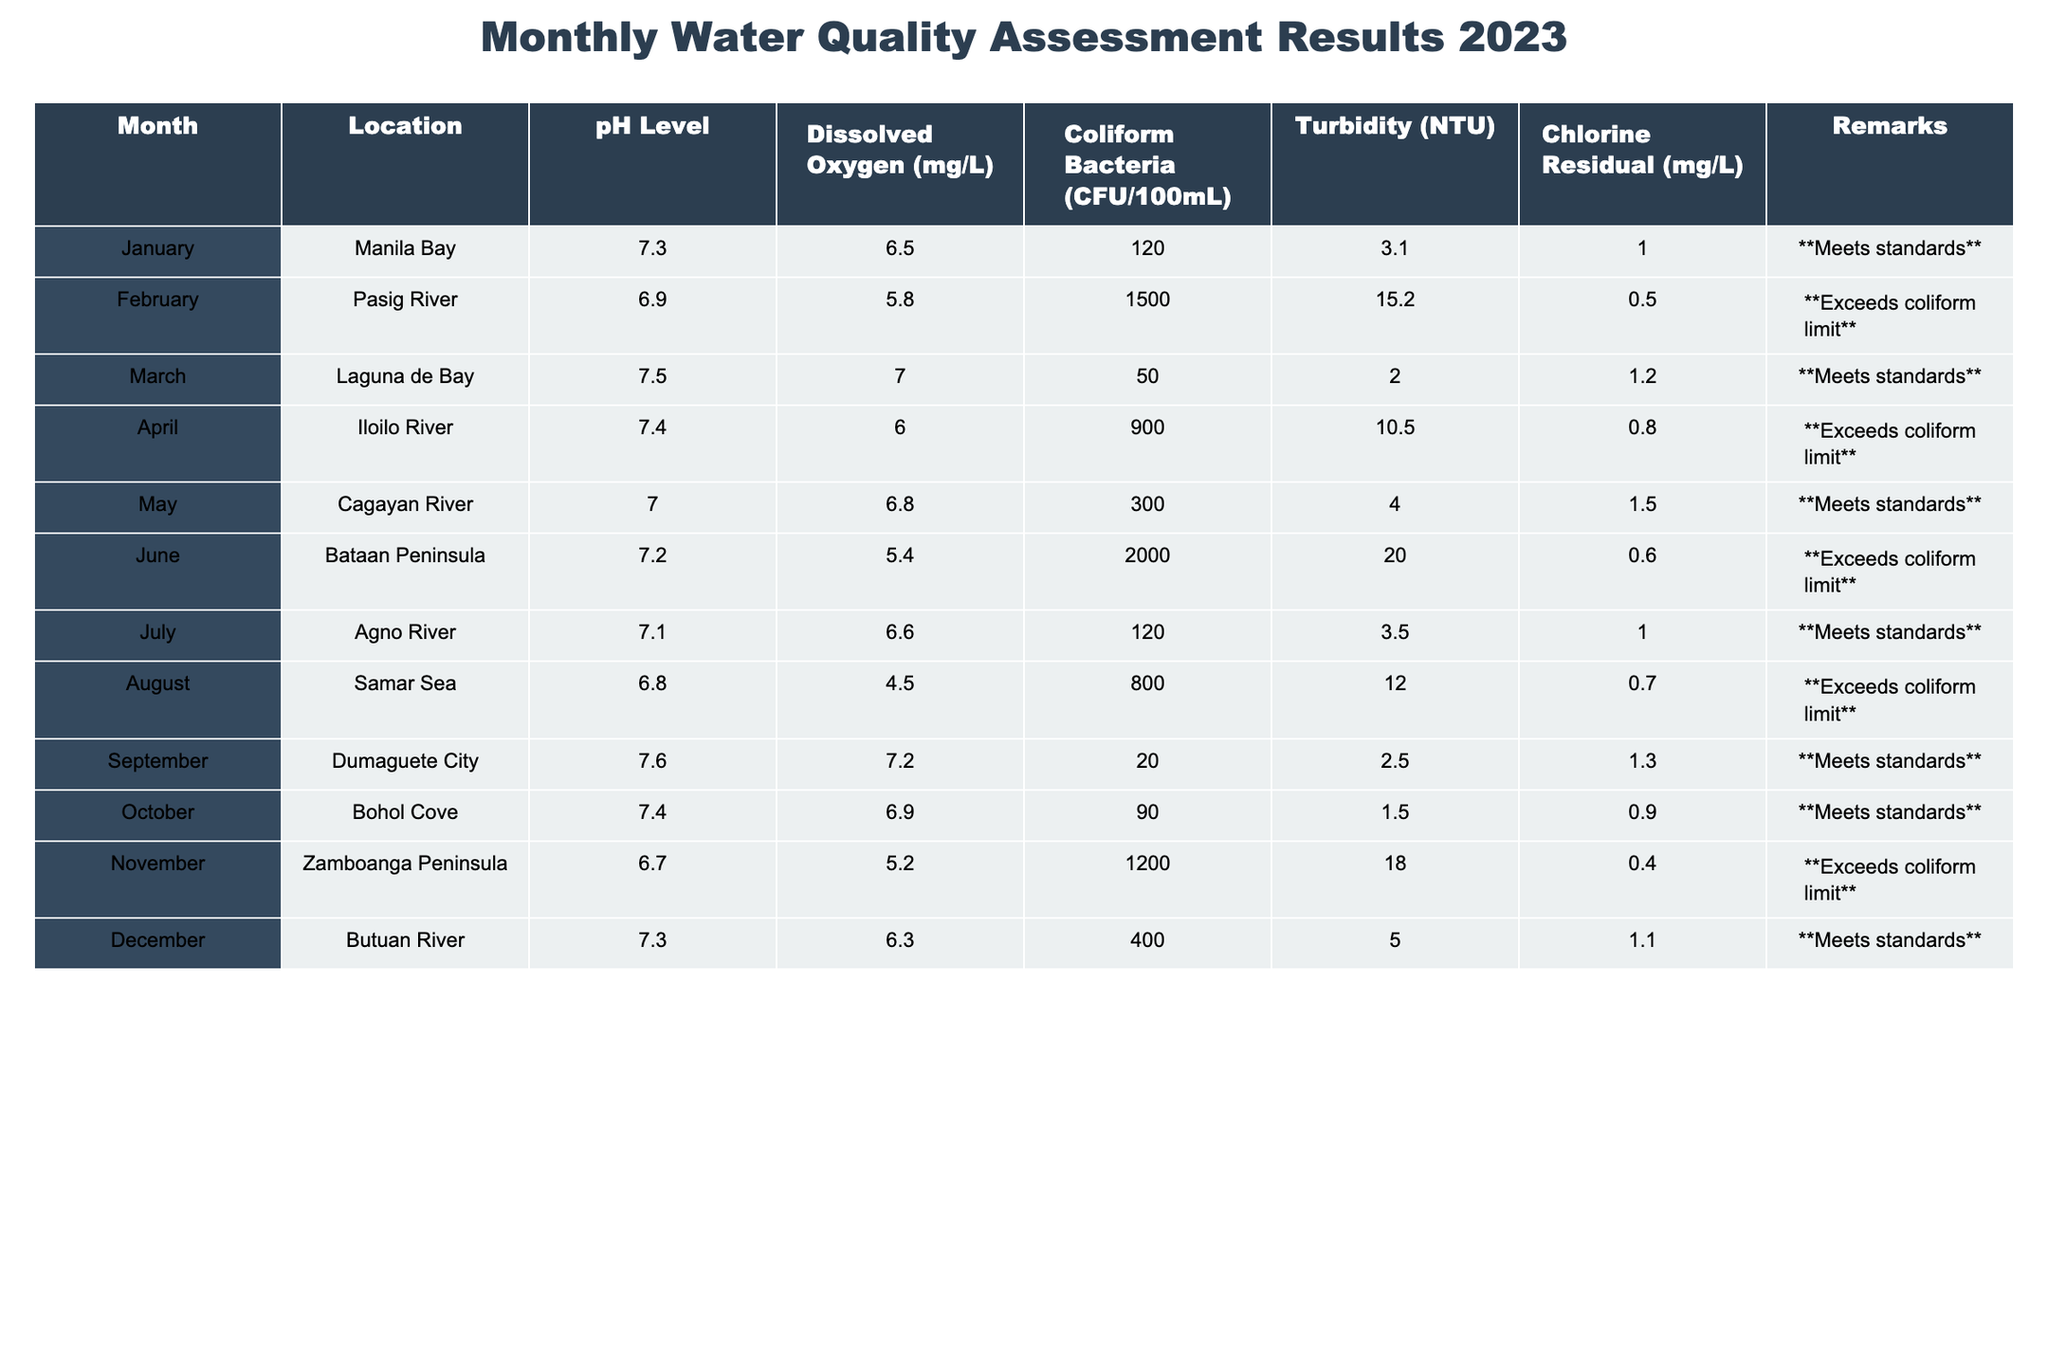What is the pH level of Pasig River in February? The table shows the pH level for Pasig River listed under February as 6.9.
Answer: 6.9 Which month had the highest dissolved oxygen level? By scanning the column for dissolved oxygen levels, March for Laguna de Bay has the highest value at 7.0 mg/L.
Answer: March What are the chlorine residual levels for locations that exceed coliform limits? Checking the records for exceeds coliform limits, they are: February (0.5 mg/L), April (0.8 mg/L), June (0.6 mg/L), August (0.7 mg/L), and November (0.4 mg/L).
Answer: 0.5, 0.8, 0.6, 0.7, 0.4 How many months had water quality that met standards? The months with water quality that met standards are January, March, May, July, September, October, and December. This totals to 7 months.
Answer: 7 What is the average turbidity level for the locations that meet standards? The turbidity levels for the months that meet standards are 3.1, 2.0, 4.0, 3.5, 2.5, 1.5, and 5.0 NTU. Their sum is 21.6, divided by 7 gives an average of 3.09 NTU.
Answer: 3.09 Did any of the months in the table meet the chlorine residual standard? Looking at chlorine residual levels, the values are 1.0, 1.2, 1.5, 1.0, 1.3, 0.9, and 1.1 mg/L for the months that meet standards, which indicates that they all meet the chlorine residual standard.
Answer: Yes Which location had the highest level of coliform bacteria and in which month? The table shows that Bataan Peninsula in June recorded the highest coliform bacteria level at 2000 CFU/100mL.
Answer: Bataan Peninsula, June How does the average pH level of locations exceeding coliform limits compare to those that meet standards? The locations exceeding coliform limits have pH levels of 6.9, 7.4, 6.8, and 6.7, resulting in an average of 6.775. The locations meeting standards have pH levels of 7.3, 7.5, 7.0, 7.4, 7.1, 7.6, 7.4, and 7.3, averaging 7.35. Comparing the two averages: 6.775 is lower than 7.35.
Answer: Exceeding limits have lower average pH What percentage of locations exceeded coliform limits? Counting the months, 5 out of the total 12 months indicated exceeding coliform limits, so the calculation is (5/12) * 100, which equals approximately 41.67%.
Answer: 41.67% 